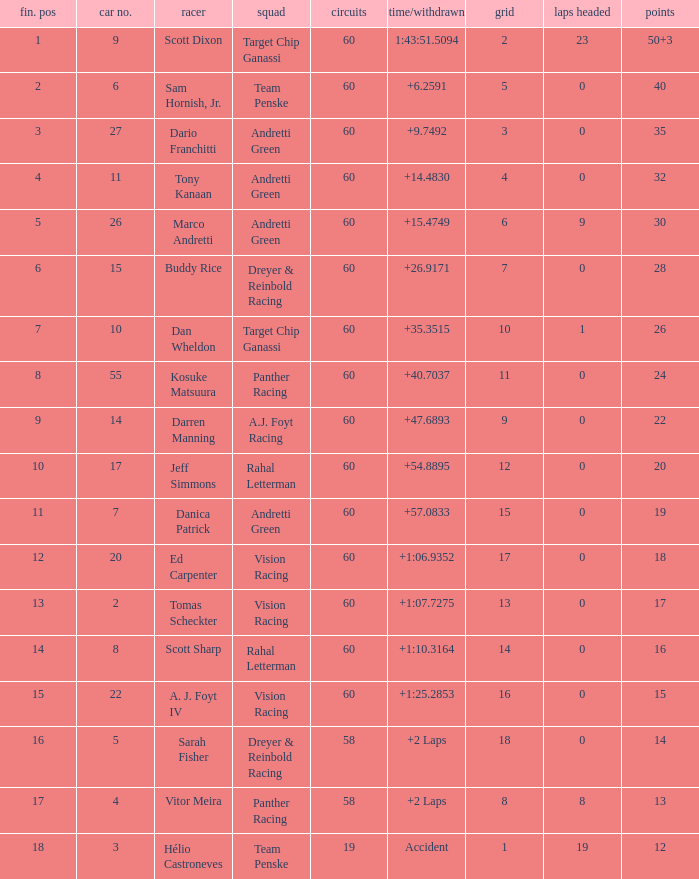Name the team of darren manning A.J. Foyt Racing. 